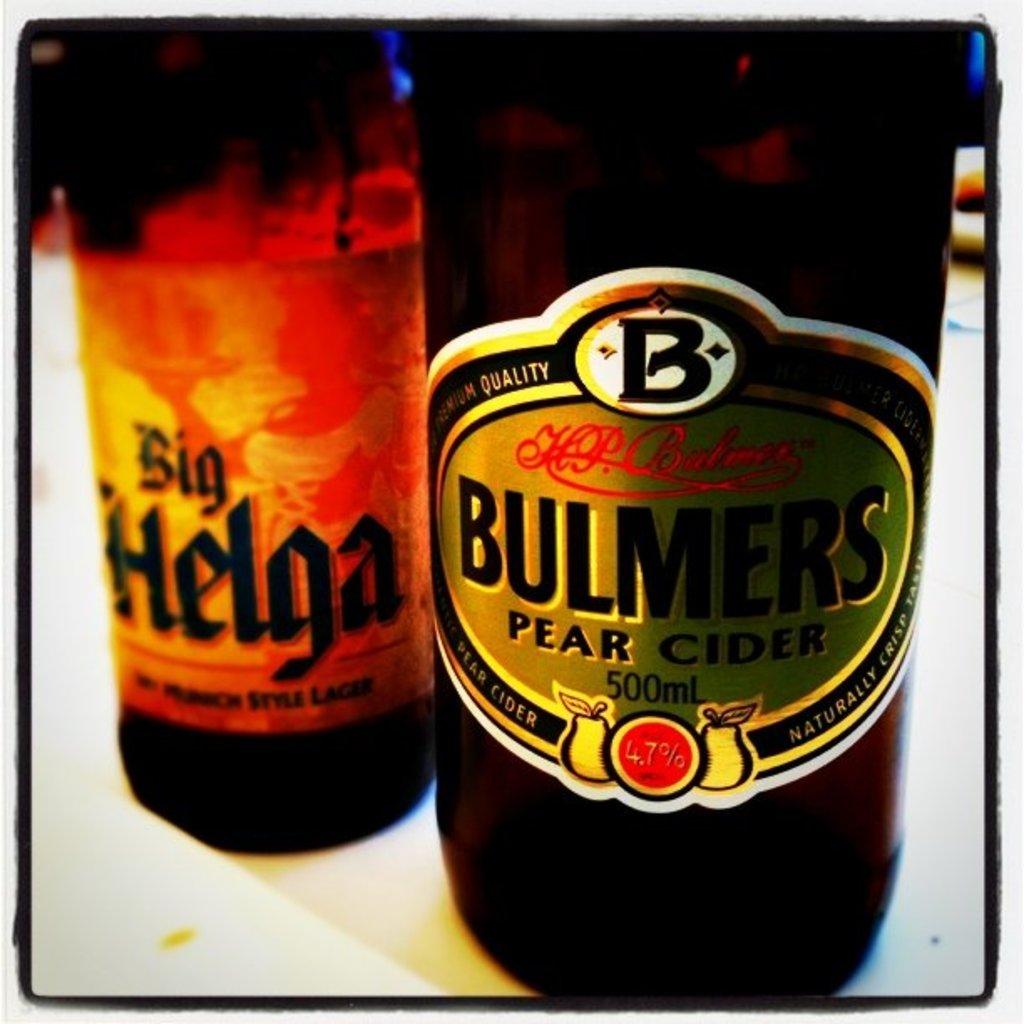What kind of drink is this?
Provide a succinct answer. Pear cider. What brand of beer on the left?
Give a very brief answer. Big helga. 